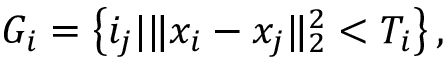Convert formula to latex. <formula><loc_0><loc_0><loc_500><loc_500>G _ { i } = \left \{ i _ { j } | \| x _ { i } - x _ { j } \| _ { 2 } ^ { 2 } < T _ { i } \right \} ,</formula> 